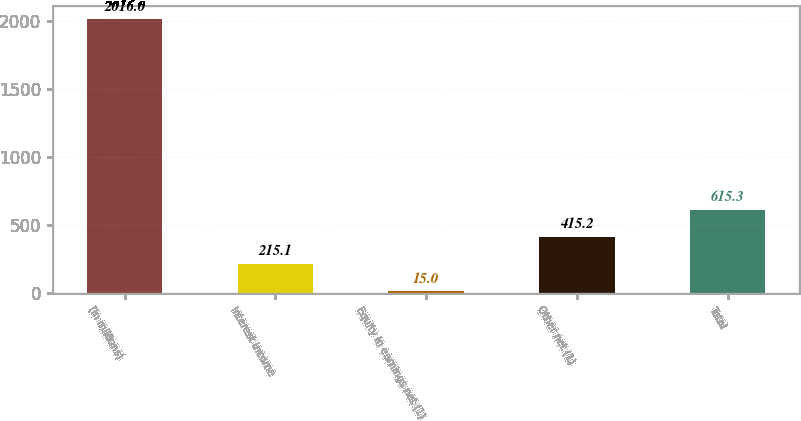Convert chart to OTSL. <chart><loc_0><loc_0><loc_500><loc_500><bar_chart><fcel>(In millions)<fcel>Interest income<fcel>Equity in earnings net (1)<fcel>Other net (1)<fcel>Total<nl><fcel>2016<fcel>215.1<fcel>15<fcel>415.2<fcel>615.3<nl></chart> 